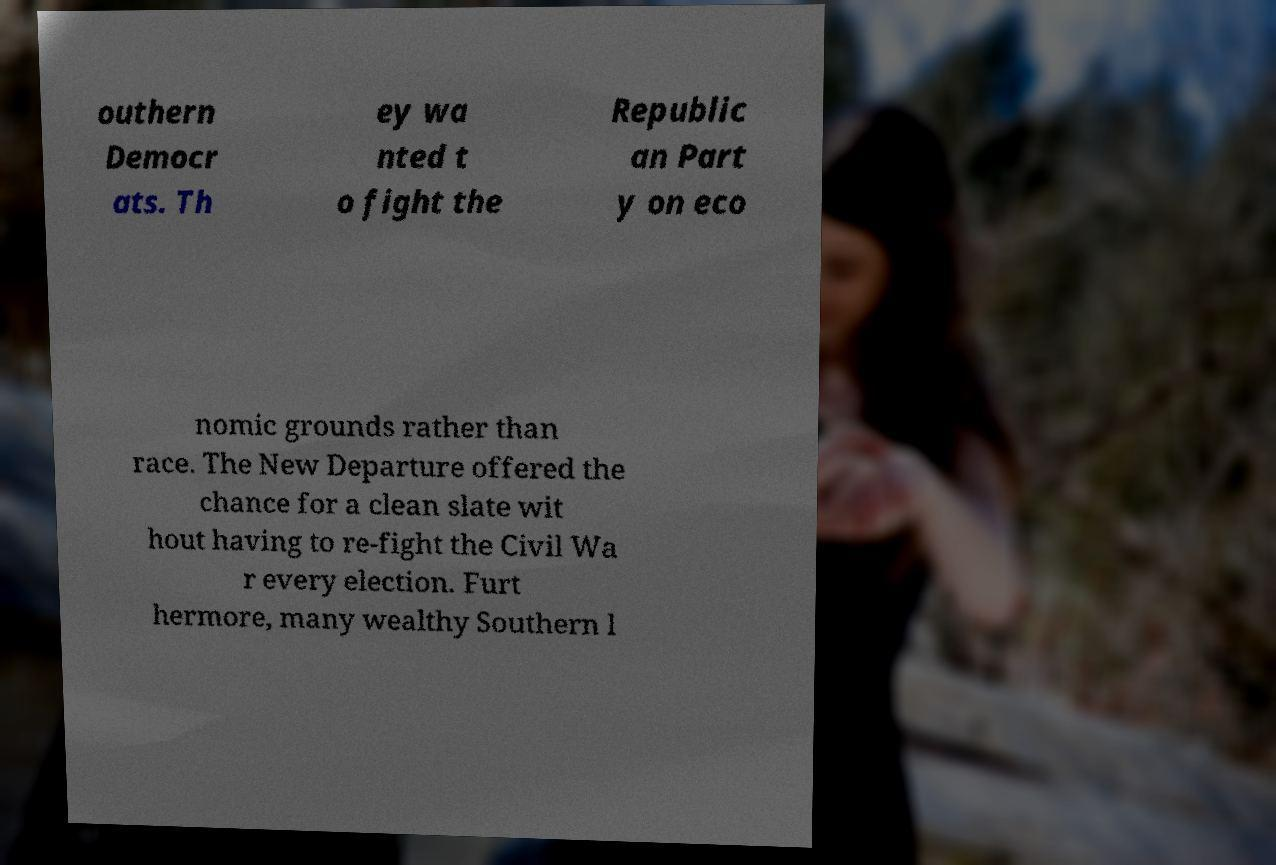Could you extract and type out the text from this image? outhern Democr ats. Th ey wa nted t o fight the Republic an Part y on eco nomic grounds rather than race. The New Departure offered the chance for a clean slate wit hout having to re-fight the Civil Wa r every election. Furt hermore, many wealthy Southern l 